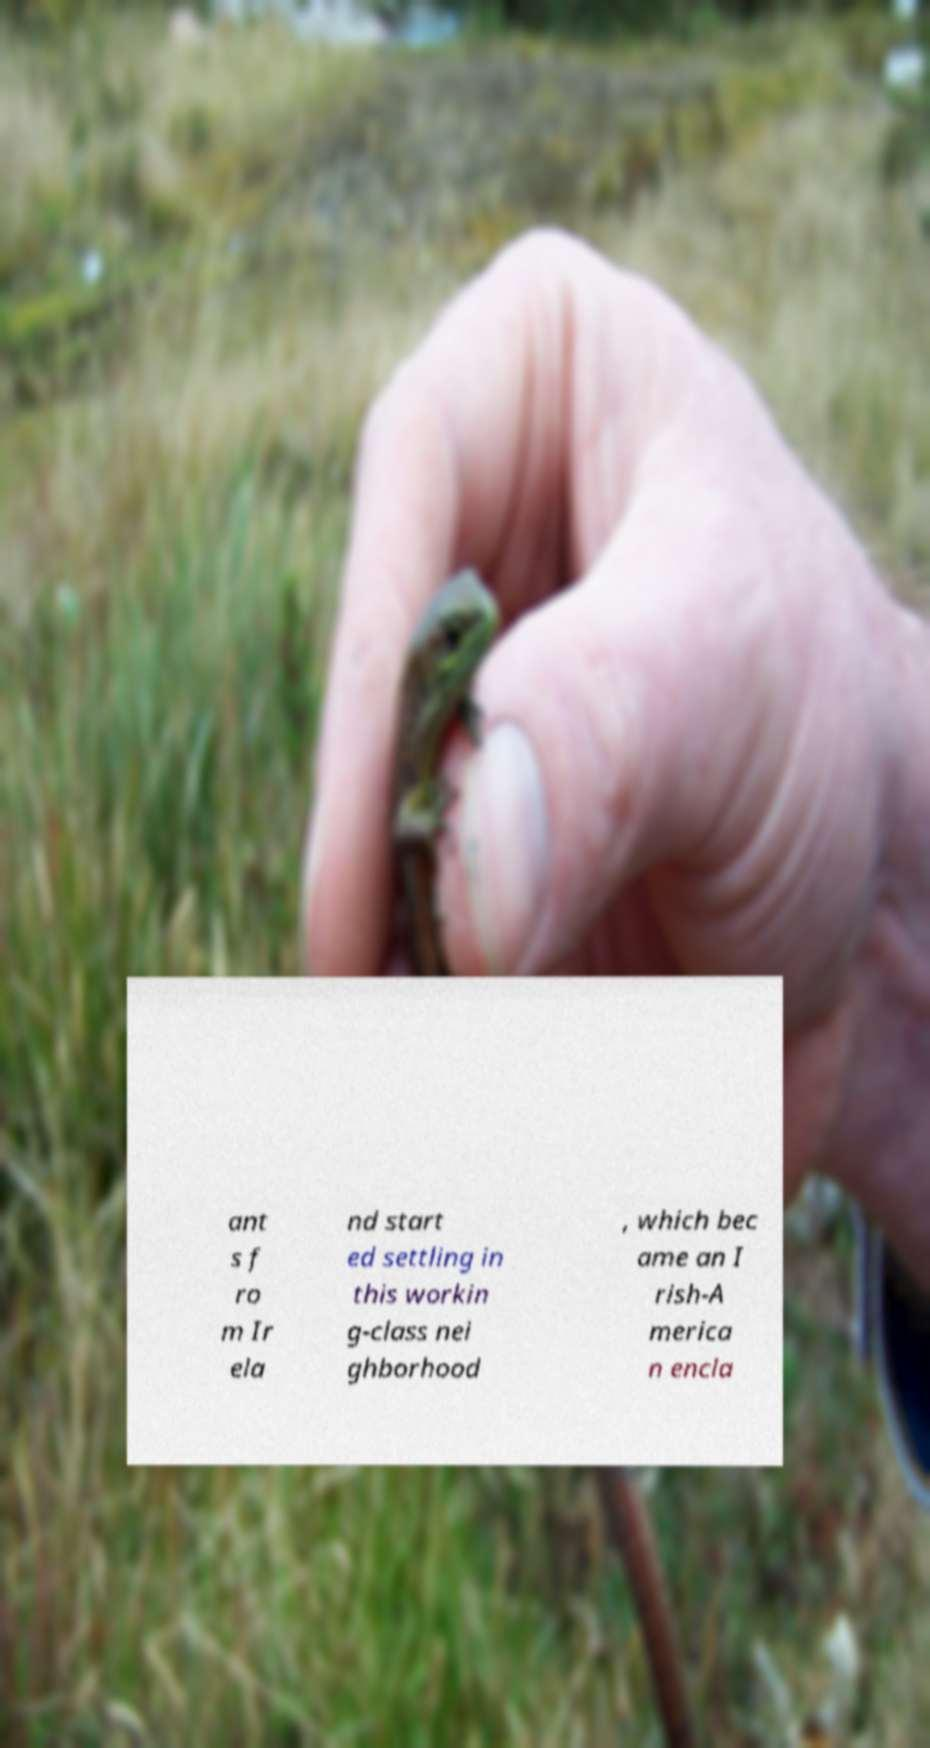For documentation purposes, I need the text within this image transcribed. Could you provide that? ant s f ro m Ir ela nd start ed settling in this workin g-class nei ghborhood , which bec ame an I rish-A merica n encla 